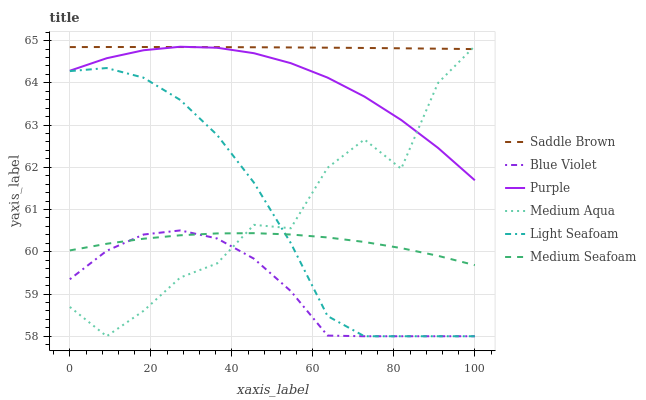Does Blue Violet have the minimum area under the curve?
Answer yes or no. Yes. Does Saddle Brown have the maximum area under the curve?
Answer yes or no. Yes. Does Medium Seafoam have the minimum area under the curve?
Answer yes or no. No. Does Medium Seafoam have the maximum area under the curve?
Answer yes or no. No. Is Saddle Brown the smoothest?
Answer yes or no. Yes. Is Medium Aqua the roughest?
Answer yes or no. Yes. Is Medium Seafoam the smoothest?
Answer yes or no. No. Is Medium Seafoam the roughest?
Answer yes or no. No. Does Medium Aqua have the lowest value?
Answer yes or no. Yes. Does Medium Seafoam have the lowest value?
Answer yes or no. No. Does Medium Aqua have the highest value?
Answer yes or no. Yes. Does Medium Seafoam have the highest value?
Answer yes or no. No. Is Medium Seafoam less than Purple?
Answer yes or no. Yes. Is Saddle Brown greater than Blue Violet?
Answer yes or no. Yes. Does Medium Aqua intersect Saddle Brown?
Answer yes or no. Yes. Is Medium Aqua less than Saddle Brown?
Answer yes or no. No. Is Medium Aqua greater than Saddle Brown?
Answer yes or no. No. Does Medium Seafoam intersect Purple?
Answer yes or no. No. 